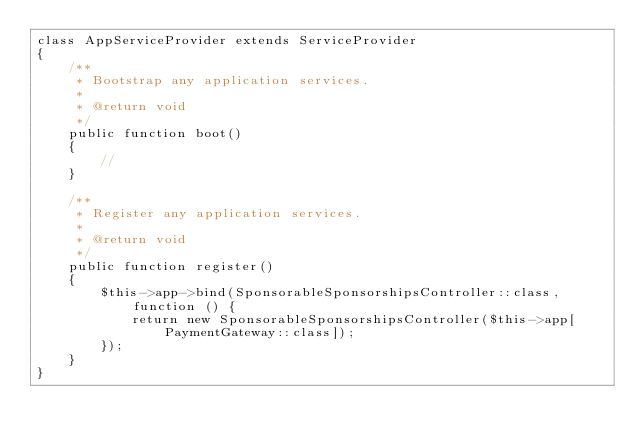Convert code to text. <code><loc_0><loc_0><loc_500><loc_500><_PHP_>class AppServiceProvider extends ServiceProvider
{
    /**
     * Bootstrap any application services.
     *
     * @return void
     */
    public function boot()
    {
        //
    }

    /**
     * Register any application services.
     *
     * @return void
     */
    public function register()
    {
        $this->app->bind(SponsorableSponsorshipsController::class, function () {
            return new SponsorableSponsorshipsController($this->app[PaymentGateway::class]);
        });
    }
}
</code> 